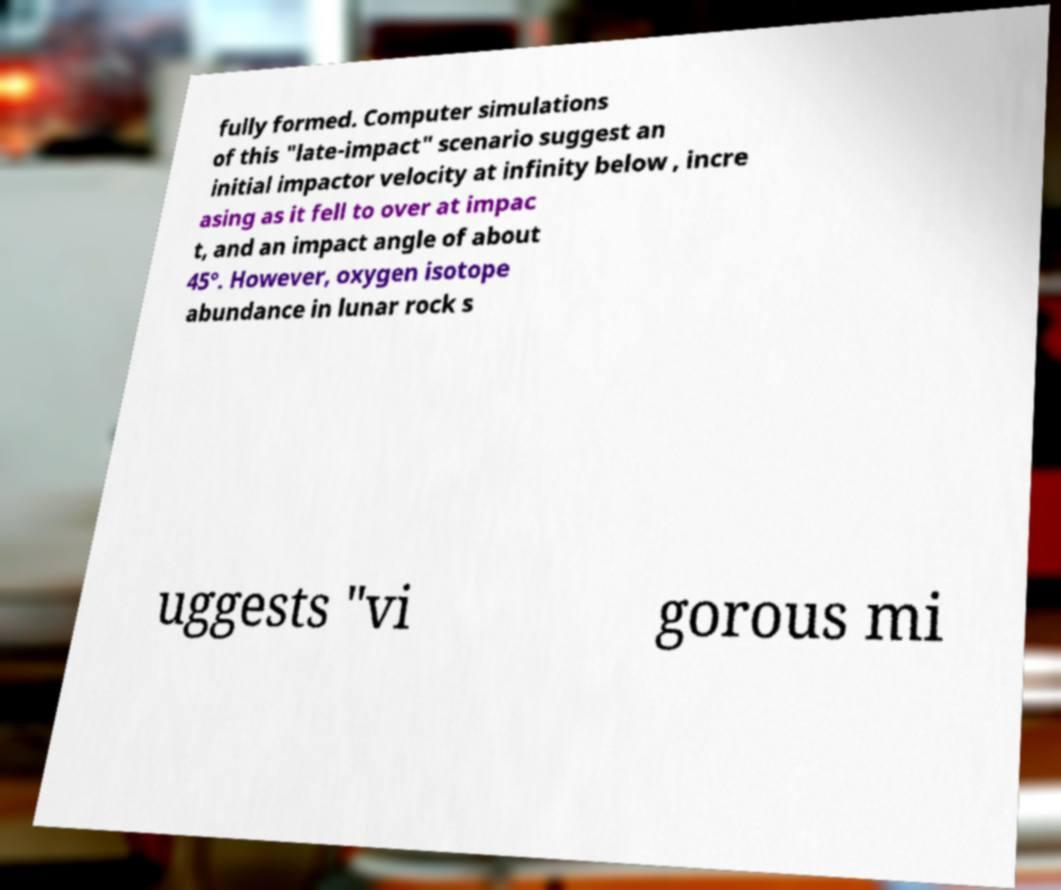What messages or text are displayed in this image? I need them in a readable, typed format. fully formed. Computer simulations of this "late-impact" scenario suggest an initial impactor velocity at infinity below , incre asing as it fell to over at impac t, and an impact angle of about 45°. However, oxygen isotope abundance in lunar rock s uggests "vi gorous mi 